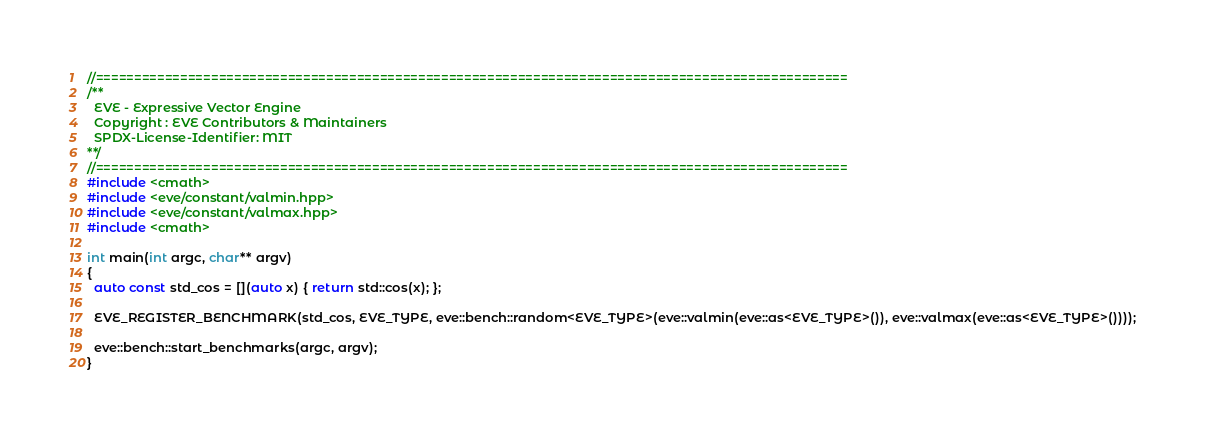<code> <loc_0><loc_0><loc_500><loc_500><_C++_>//==================================================================================================
/**
  EVE - Expressive Vector Engine
  Copyright : EVE Contributors & Maintainers
  SPDX-License-Identifier: MIT
**/
//==================================================================================================
#include <cmath>
#include <eve/constant/valmin.hpp>
#include <eve/constant/valmax.hpp>
#include <cmath>

int main(int argc, char** argv)
{
  auto const std_cos = [](auto x) { return std::cos(x); };

  EVE_REGISTER_BENCHMARK(std_cos, EVE_TYPE, eve::bench::random<EVE_TYPE>(eve::valmin(eve::as<EVE_TYPE>()), eve::valmax(eve::as<EVE_TYPE>())));

  eve::bench::start_benchmarks(argc, argv);
}
</code> 